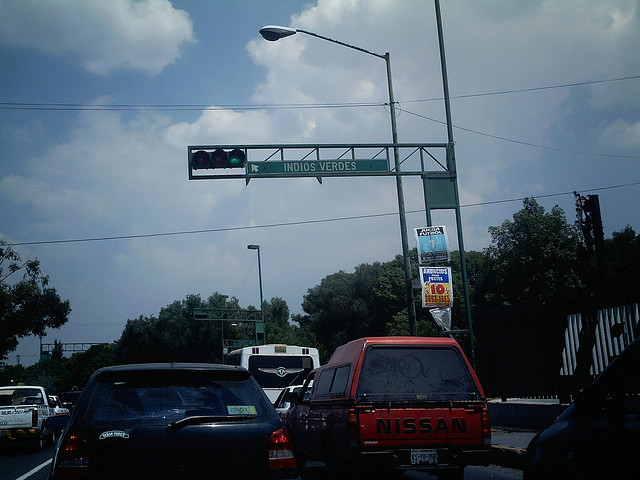<image>What type of truck is on the street? I don't know what type of truck is on the street. It can be a van, a Nissan, or a pickup. What image is in the circle on the black car? It is ambiguous what image is in the circle on the black car. It may be a sticker. What is the sign on the right for? It's unknown what the sign on the right is for. It could possibly be for a sale, Indios Verdes, a store, street sign, direction or a speed limit. In what city is this scene from? I am not sure which city this scene is from. It could be a multitude of cities such as 'Boston', 'San Jose', 'Madrid', or 'Sao Paulo'. What type of truck is on the street? I don't know what type of truck is on the street. It can be seen as a van, nissan, pickup, or SUV. What image is in the circle on the black car? I don't know what image is in the circle on the black car. There can be a variety of possibilities, such as a rectangle, a sticker, or even nothing. What is the sign on the right for? I don't know what the sign on the right is for. It can be for sale, store, street sign, or speed limit. In what city is this scene from? I am not sure the city where this scene is from. It could be Indios Verdes, Boston, Sao Paulo, San Jose, Mexico, Madrid, or Florida. 